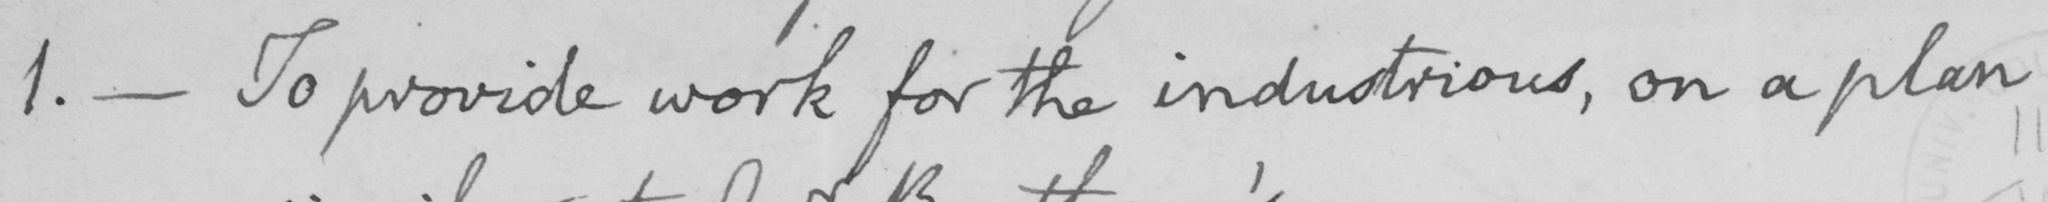Please provide the text content of this handwritten line. 1 .  _  To provide work for the industrious , on a plan 